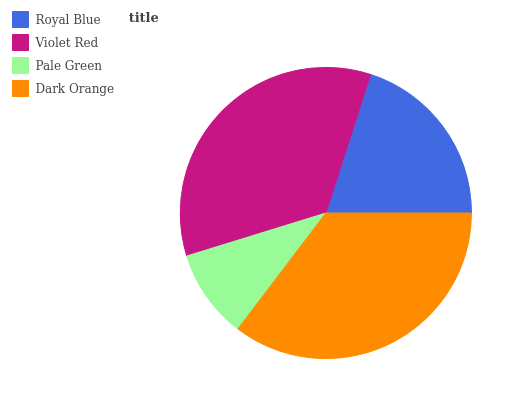Is Pale Green the minimum?
Answer yes or no. Yes. Is Dark Orange the maximum?
Answer yes or no. Yes. Is Violet Red the minimum?
Answer yes or no. No. Is Violet Red the maximum?
Answer yes or no. No. Is Violet Red greater than Royal Blue?
Answer yes or no. Yes. Is Royal Blue less than Violet Red?
Answer yes or no. Yes. Is Royal Blue greater than Violet Red?
Answer yes or no. No. Is Violet Red less than Royal Blue?
Answer yes or no. No. Is Violet Red the high median?
Answer yes or no. Yes. Is Royal Blue the low median?
Answer yes or no. Yes. Is Pale Green the high median?
Answer yes or no. No. Is Pale Green the low median?
Answer yes or no. No. 